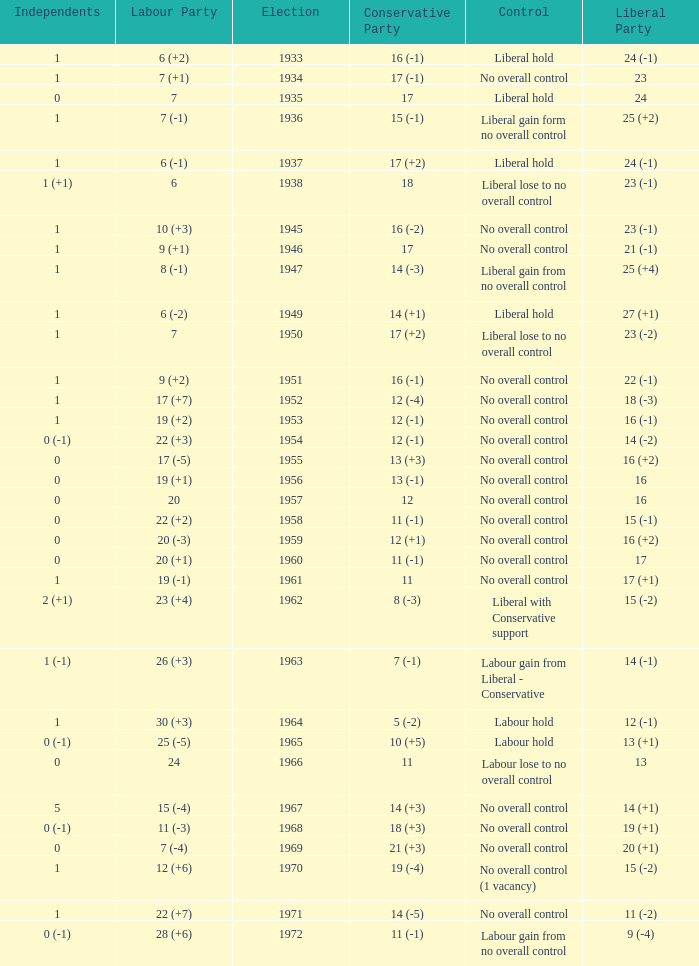What was the control for the year with a Conservative Party result of 10 (+5)? Labour hold. 